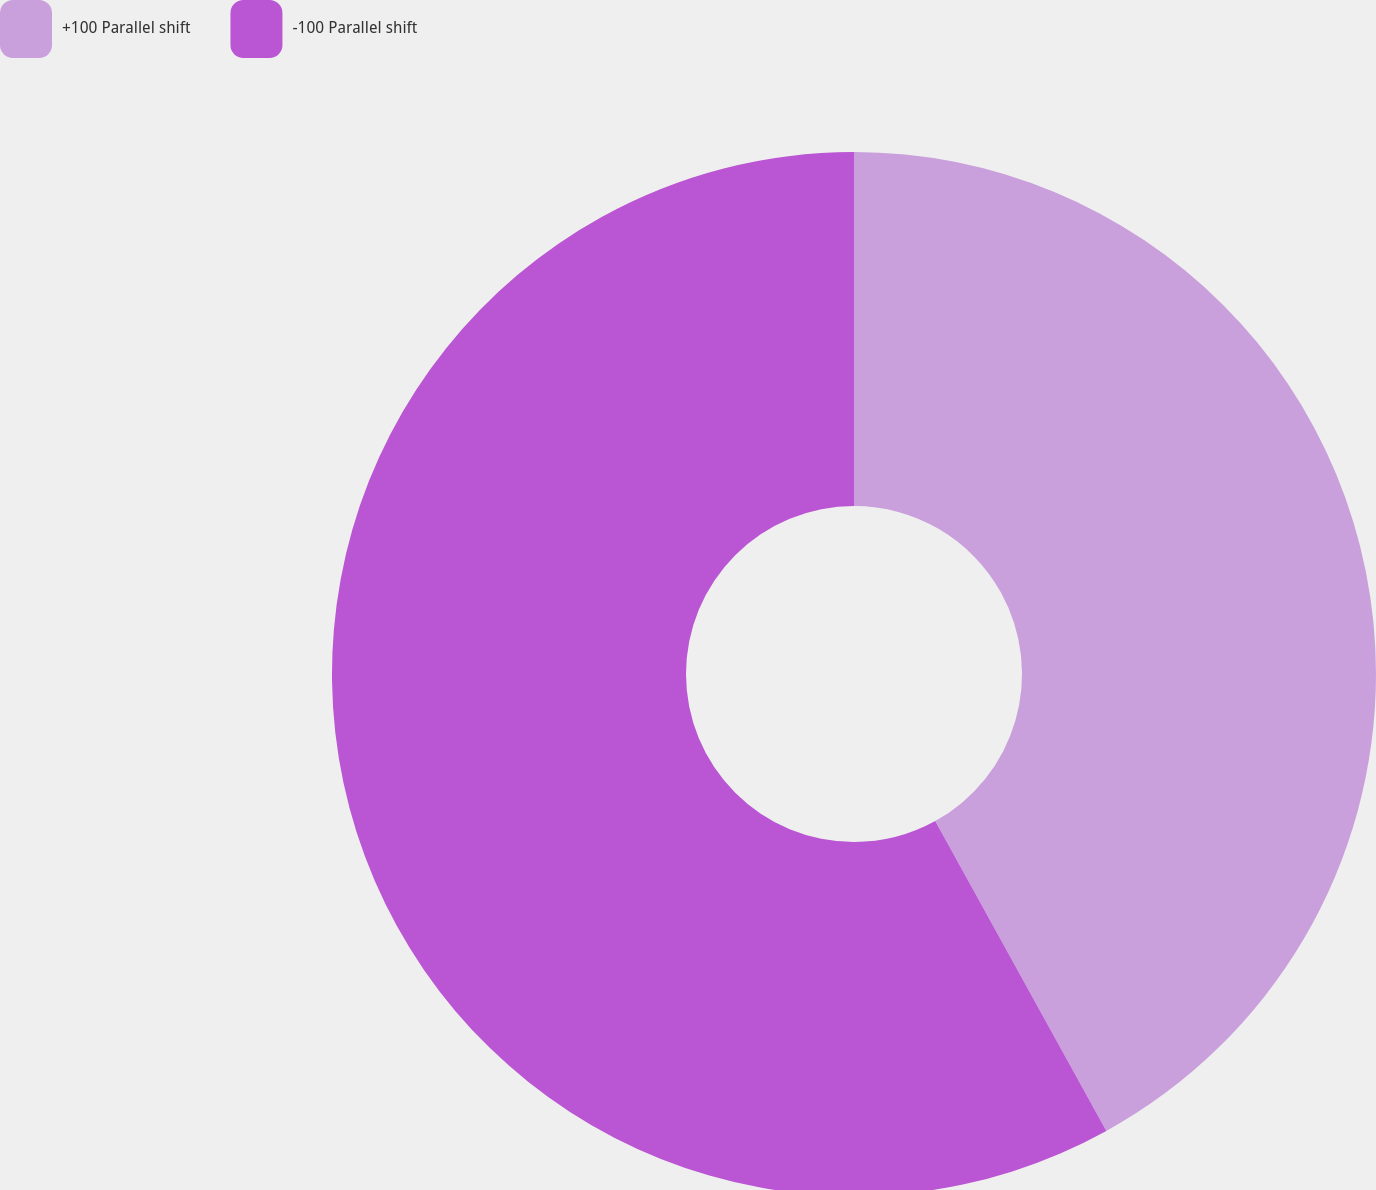Convert chart. <chart><loc_0><loc_0><loc_500><loc_500><pie_chart><fcel>+100 Parallel shift<fcel>-100 Parallel shift<nl><fcel>41.97%<fcel>58.03%<nl></chart> 